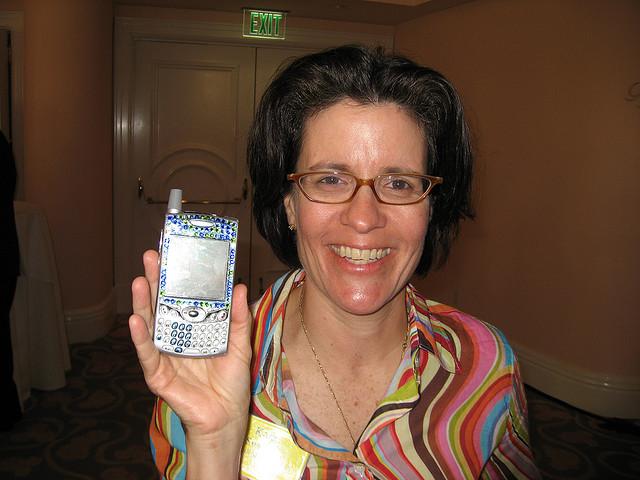How many cell phones does he have?
Be succinct. 1. Is she holding a painted mobile?
Write a very short answer. Yes. What color are the frames of the glasses?
Quick response, please. Brown. What is the woman doing with her eye?
Be succinct. Looking. What is this person holding?
Give a very brief answer. Cell phone. What color is the woman's hair?
Keep it brief. Brown. Is that a blackberry?
Keep it brief. Yes. 